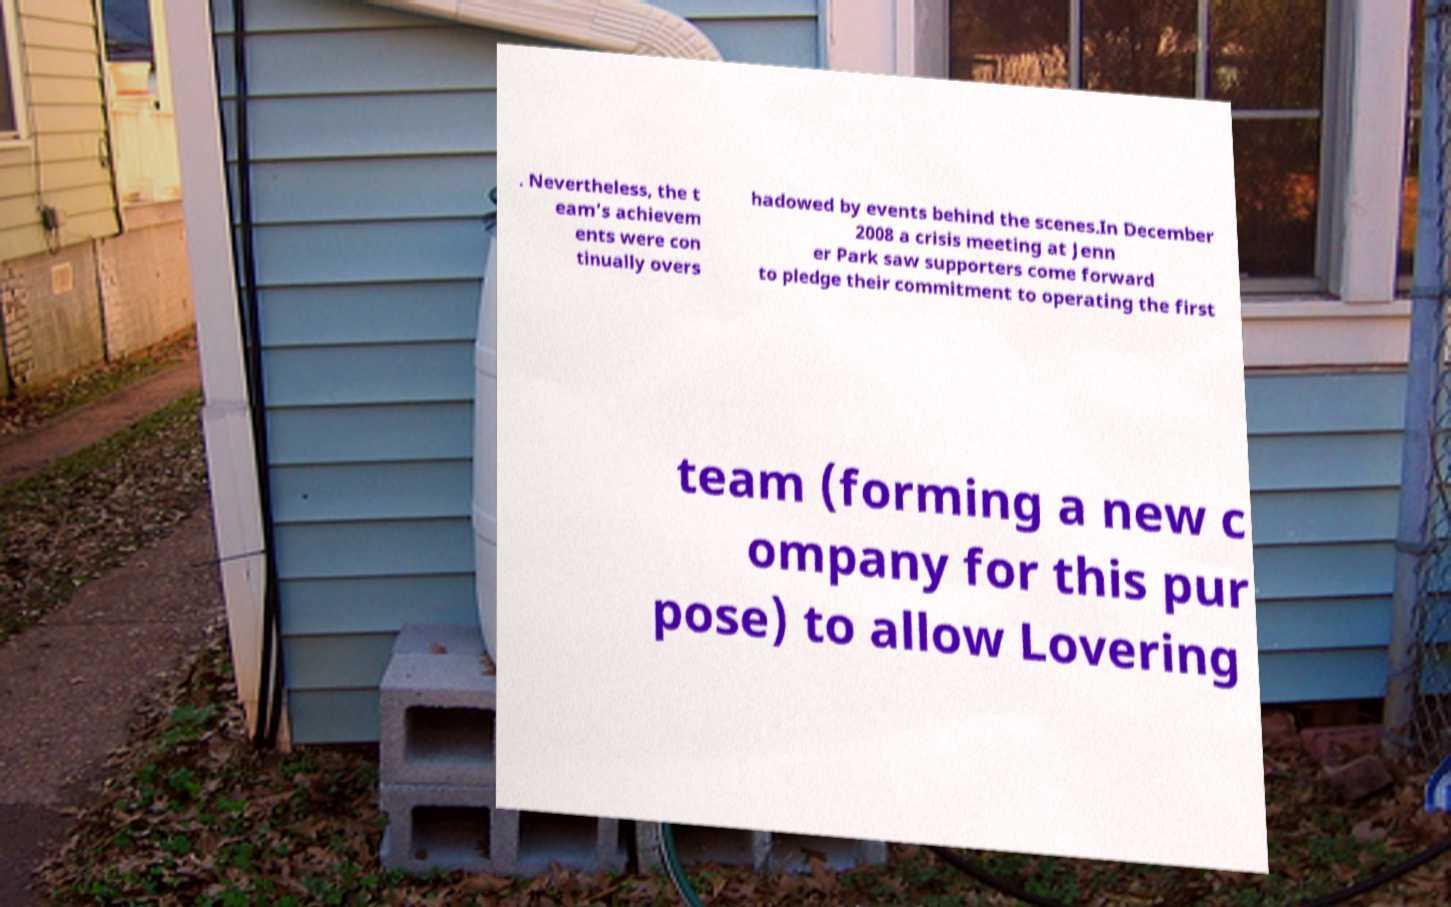Could you assist in decoding the text presented in this image and type it out clearly? . Nevertheless, the t eam's achievem ents were con tinually overs hadowed by events behind the scenes.In December 2008 a crisis meeting at Jenn er Park saw supporters come forward to pledge their commitment to operating the first team (forming a new c ompany for this pur pose) to allow Lovering 